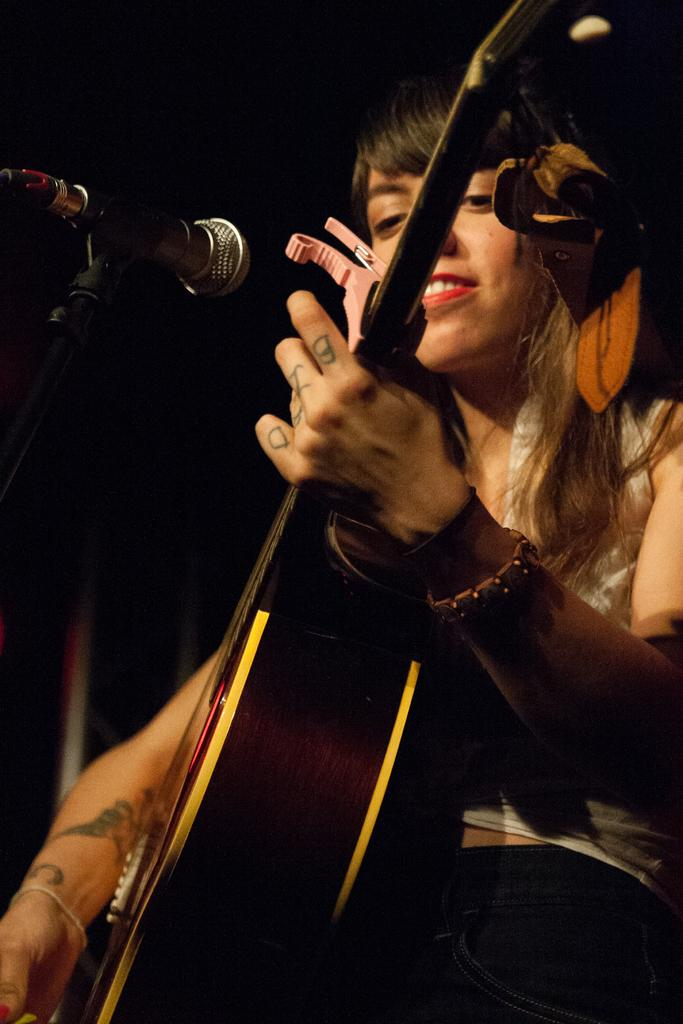Who is the main subject in the picture? There is a woman in the picture. What is the woman doing in the image? The woman is playing a guitar. What object is in front of the woman? There is a microphone in front of the woman. What news story is the woman discussing while playing the guitar? There is no indication in the image that the woman is discussing any news stories while playing the guitar. 